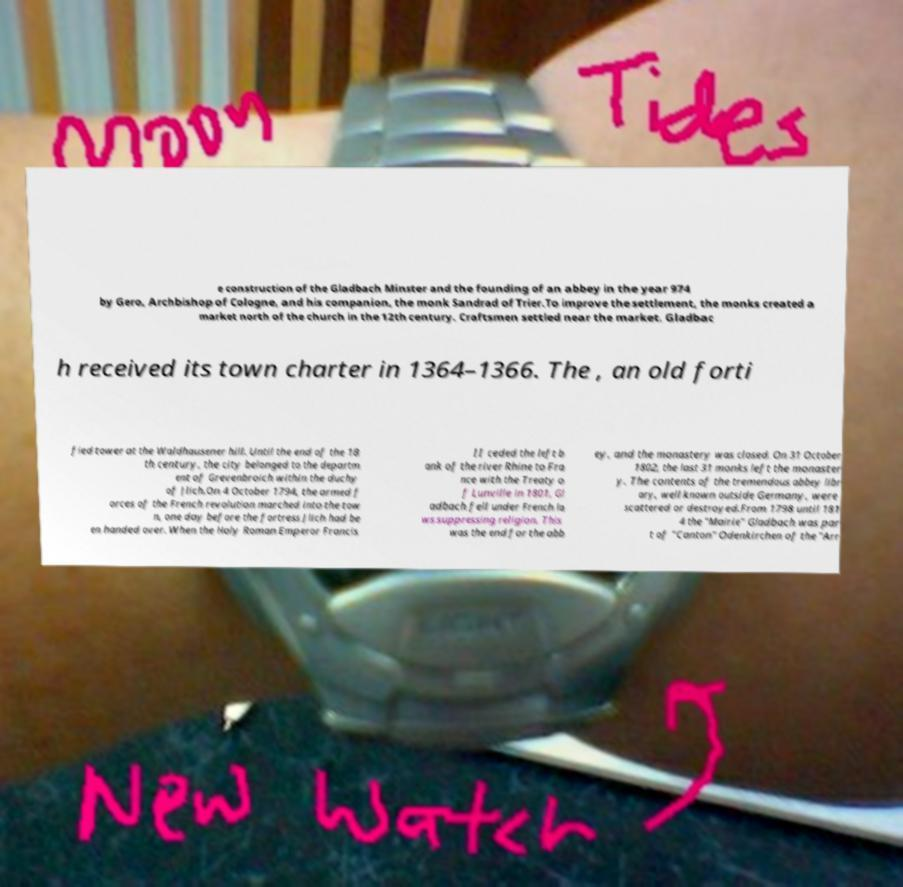Please identify and transcribe the text found in this image. e construction of the Gladbach Minster and the founding of an abbey in the year 974 by Gero, Archbishop of Cologne, and his companion, the monk Sandrad of Trier.To improve the settlement, the monks created a market north of the church in the 12th century. Craftsmen settled near the market. Gladbac h received its town charter in 1364–1366. The , an old forti fied tower at the Waldhausener hill. Until the end of the 18 th century, the city belonged to the departm ent of Grevenbroich within the duchy of Jlich.On 4 October 1794, the armed f orces of the French revolution marched into the tow n, one day before the fortress Jlich had be en handed over. When the Holy Roman Emperor Francis II ceded the left b ank of the river Rhine to Fra nce with the Treaty o f Lunville in 1801, Gl adbach fell under French la ws suppressing religion. This was the end for the abb ey, and the monastery was closed. On 31 October 1802, the last 31 monks left the monaster y. The contents of the tremendous abbey libr ary, well known outside Germany, were scattered or destroyed.From 1798 until 181 4 the "Mairie" Gladbach was par t of "Canton" Odenkirchen of the "Arr 